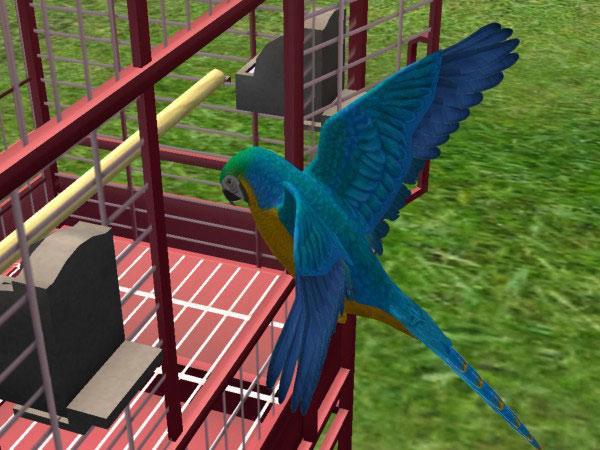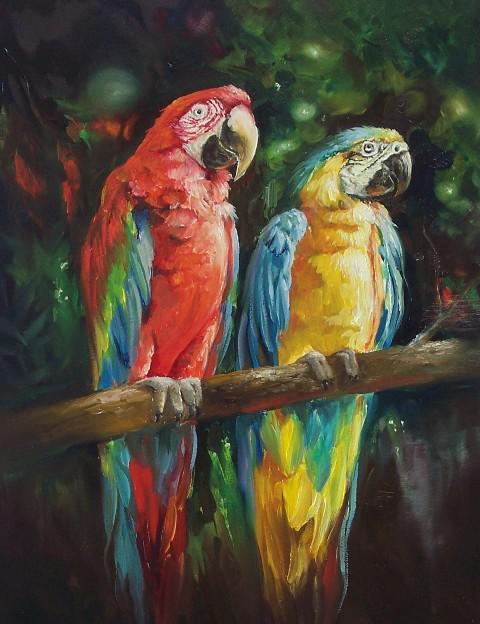The first image is the image on the left, the second image is the image on the right. For the images shown, is this caption "All of the colorful birds are flying in the air." true? Answer yes or no. No. The first image is the image on the left, the second image is the image on the right. Examine the images to the left and right. Is the description "All birds have yellow and blue coloring and all birds are in flight." accurate? Answer yes or no. No. The first image is the image on the left, the second image is the image on the right. Evaluate the accuracy of this statement regarding the images: "There are two real birds with white faces in black beaks sitting next to each other on a branch.". Is it true? Answer yes or no. No. 